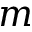Convert formula to latex. <formula><loc_0><loc_0><loc_500><loc_500>m</formula> 